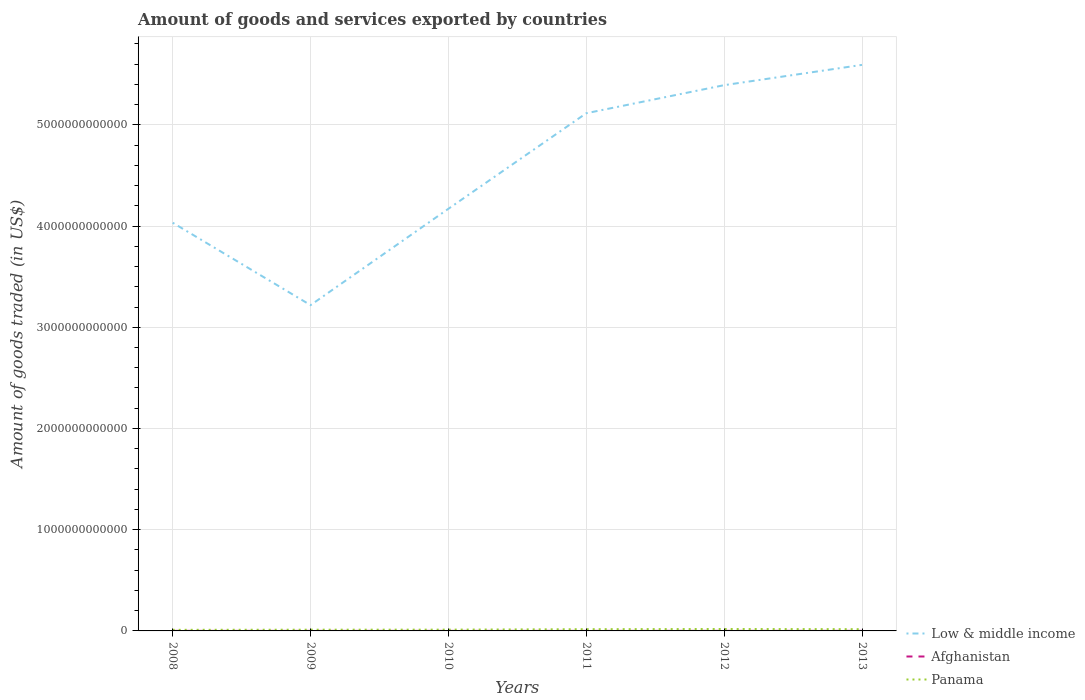How many different coloured lines are there?
Offer a terse response. 3. Is the number of lines equal to the number of legend labels?
Your answer should be compact. Yes. Across all years, what is the maximum total amount of goods and services exported in Afghanistan?
Provide a succinct answer. 4.06e+08. In which year was the total amount of goods and services exported in Panama maximum?
Offer a very short reply. 2008. What is the total total amount of goods and services exported in Low & middle income in the graph?
Your answer should be compact. -9.52e+11. What is the difference between the highest and the second highest total amount of goods and services exported in Panama?
Your answer should be compact. 8.05e+09. What is the difference between the highest and the lowest total amount of goods and services exported in Panama?
Make the answer very short. 3. Is the total amount of goods and services exported in Afghanistan strictly greater than the total amount of goods and services exported in Panama over the years?
Your answer should be compact. Yes. What is the difference between two consecutive major ticks on the Y-axis?
Give a very brief answer. 1.00e+12. Are the values on the major ticks of Y-axis written in scientific E-notation?
Ensure brevity in your answer.  No. How many legend labels are there?
Ensure brevity in your answer.  3. How are the legend labels stacked?
Provide a short and direct response. Vertical. What is the title of the graph?
Give a very brief answer. Amount of goods and services exported by countries. What is the label or title of the X-axis?
Make the answer very short. Years. What is the label or title of the Y-axis?
Your response must be concise. Amount of goods traded (in US$). What is the Amount of goods traded (in US$) of Low & middle income in 2008?
Provide a succinct answer. 4.03e+12. What is the Amount of goods traded (in US$) in Afghanistan in 2008?
Give a very brief answer. 5.63e+08. What is the Amount of goods traded (in US$) of Panama in 2008?
Give a very brief answer. 1.08e+1. What is the Amount of goods traded (in US$) of Low & middle income in 2009?
Provide a short and direct response. 3.22e+12. What is the Amount of goods traded (in US$) of Afghanistan in 2009?
Ensure brevity in your answer.  4.06e+08. What is the Amount of goods traded (in US$) of Panama in 2009?
Offer a very short reply. 1.21e+1. What is the Amount of goods traded (in US$) in Low & middle income in 2010?
Give a very brief answer. 4.17e+12. What is the Amount of goods traded (in US$) in Afghanistan in 2010?
Provide a succinct answer. 4.53e+08. What is the Amount of goods traded (in US$) in Panama in 2010?
Offer a very short reply. 1.27e+1. What is the Amount of goods traded (in US$) in Low & middle income in 2011?
Your response must be concise. 5.11e+12. What is the Amount of goods traded (in US$) in Afghanistan in 2011?
Your answer should be very brief. 4.31e+08. What is the Amount of goods traded (in US$) in Panama in 2011?
Provide a succinct answer. 1.70e+1. What is the Amount of goods traded (in US$) in Low & middle income in 2012?
Your answer should be very brief. 5.39e+12. What is the Amount of goods traded (in US$) of Afghanistan in 2012?
Make the answer very short. 6.20e+08. What is the Amount of goods traded (in US$) of Panama in 2012?
Offer a very short reply. 1.88e+1. What is the Amount of goods traded (in US$) of Low & middle income in 2013?
Provide a succinct answer. 5.59e+12. What is the Amount of goods traded (in US$) of Afghanistan in 2013?
Offer a terse response. 6.21e+08. What is the Amount of goods traded (in US$) of Panama in 2013?
Ensure brevity in your answer.  1.72e+1. Across all years, what is the maximum Amount of goods traded (in US$) in Low & middle income?
Your response must be concise. 5.59e+12. Across all years, what is the maximum Amount of goods traded (in US$) of Afghanistan?
Offer a terse response. 6.21e+08. Across all years, what is the maximum Amount of goods traded (in US$) of Panama?
Give a very brief answer. 1.88e+1. Across all years, what is the minimum Amount of goods traded (in US$) of Low & middle income?
Offer a terse response. 3.22e+12. Across all years, what is the minimum Amount of goods traded (in US$) in Afghanistan?
Your response must be concise. 4.06e+08. Across all years, what is the minimum Amount of goods traded (in US$) of Panama?
Ensure brevity in your answer.  1.08e+1. What is the total Amount of goods traded (in US$) in Low & middle income in the graph?
Your answer should be very brief. 2.75e+13. What is the total Amount of goods traded (in US$) of Afghanistan in the graph?
Offer a terse response. 3.09e+09. What is the total Amount of goods traded (in US$) in Panama in the graph?
Your answer should be compact. 8.85e+1. What is the difference between the Amount of goods traded (in US$) of Low & middle income in 2008 and that in 2009?
Your response must be concise. 8.14e+11. What is the difference between the Amount of goods traded (in US$) of Afghanistan in 2008 and that in 2009?
Your answer should be very brief. 1.57e+08. What is the difference between the Amount of goods traded (in US$) in Panama in 2008 and that in 2009?
Make the answer very short. -1.28e+09. What is the difference between the Amount of goods traded (in US$) of Low & middle income in 2008 and that in 2010?
Keep it short and to the point. -1.38e+11. What is the difference between the Amount of goods traded (in US$) of Afghanistan in 2008 and that in 2010?
Ensure brevity in your answer.  1.10e+08. What is the difference between the Amount of goods traded (in US$) of Panama in 2008 and that in 2010?
Your answer should be compact. -1.89e+09. What is the difference between the Amount of goods traded (in US$) in Low & middle income in 2008 and that in 2011?
Offer a very short reply. -1.08e+12. What is the difference between the Amount of goods traded (in US$) in Afghanistan in 2008 and that in 2011?
Your answer should be compact. 1.32e+08. What is the difference between the Amount of goods traded (in US$) in Panama in 2008 and that in 2011?
Give a very brief answer. -6.20e+09. What is the difference between the Amount of goods traded (in US$) of Low & middle income in 2008 and that in 2012?
Provide a succinct answer. -1.36e+12. What is the difference between the Amount of goods traded (in US$) of Afghanistan in 2008 and that in 2012?
Your answer should be compact. -5.67e+07. What is the difference between the Amount of goods traded (in US$) in Panama in 2008 and that in 2012?
Keep it short and to the point. -8.05e+09. What is the difference between the Amount of goods traded (in US$) in Low & middle income in 2008 and that in 2013?
Your answer should be very brief. -1.56e+12. What is the difference between the Amount of goods traded (in US$) in Afghanistan in 2008 and that in 2013?
Your response must be concise. -5.77e+07. What is the difference between the Amount of goods traded (in US$) in Panama in 2008 and that in 2013?
Your answer should be compact. -6.37e+09. What is the difference between the Amount of goods traded (in US$) in Low & middle income in 2009 and that in 2010?
Offer a terse response. -9.52e+11. What is the difference between the Amount of goods traded (in US$) of Afghanistan in 2009 and that in 2010?
Offer a very short reply. -4.72e+07. What is the difference between the Amount of goods traded (in US$) of Panama in 2009 and that in 2010?
Your response must be concise. -6.16e+08. What is the difference between the Amount of goods traded (in US$) in Low & middle income in 2009 and that in 2011?
Provide a short and direct response. -1.90e+12. What is the difference between the Amount of goods traded (in US$) of Afghanistan in 2009 and that in 2011?
Ensure brevity in your answer.  -2.45e+07. What is the difference between the Amount of goods traded (in US$) in Panama in 2009 and that in 2011?
Offer a terse response. -4.92e+09. What is the difference between the Amount of goods traded (in US$) in Low & middle income in 2009 and that in 2012?
Provide a short and direct response. -2.17e+12. What is the difference between the Amount of goods traded (in US$) of Afghanistan in 2009 and that in 2012?
Your answer should be compact. -2.14e+08. What is the difference between the Amount of goods traded (in US$) in Panama in 2009 and that in 2012?
Offer a terse response. -6.77e+09. What is the difference between the Amount of goods traded (in US$) of Low & middle income in 2009 and that in 2013?
Your answer should be very brief. -2.37e+12. What is the difference between the Amount of goods traded (in US$) of Afghanistan in 2009 and that in 2013?
Your answer should be very brief. -2.15e+08. What is the difference between the Amount of goods traded (in US$) in Panama in 2009 and that in 2013?
Make the answer very short. -5.09e+09. What is the difference between the Amount of goods traded (in US$) of Low & middle income in 2010 and that in 2011?
Your answer should be compact. -9.44e+11. What is the difference between the Amount of goods traded (in US$) of Afghanistan in 2010 and that in 2011?
Your answer should be very brief. 2.27e+07. What is the difference between the Amount of goods traded (in US$) of Panama in 2010 and that in 2011?
Provide a short and direct response. -4.30e+09. What is the difference between the Amount of goods traded (in US$) in Low & middle income in 2010 and that in 2012?
Your answer should be compact. -1.22e+12. What is the difference between the Amount of goods traded (in US$) of Afghanistan in 2010 and that in 2012?
Make the answer very short. -1.66e+08. What is the difference between the Amount of goods traded (in US$) of Panama in 2010 and that in 2012?
Keep it short and to the point. -6.15e+09. What is the difference between the Amount of goods traded (in US$) in Low & middle income in 2010 and that in 2013?
Provide a short and direct response. -1.42e+12. What is the difference between the Amount of goods traded (in US$) in Afghanistan in 2010 and that in 2013?
Your answer should be compact. -1.67e+08. What is the difference between the Amount of goods traded (in US$) in Panama in 2010 and that in 2013?
Your answer should be compact. -4.47e+09. What is the difference between the Amount of goods traded (in US$) of Low & middle income in 2011 and that in 2012?
Ensure brevity in your answer.  -2.77e+11. What is the difference between the Amount of goods traded (in US$) of Afghanistan in 2011 and that in 2012?
Provide a short and direct response. -1.89e+08. What is the difference between the Amount of goods traded (in US$) in Panama in 2011 and that in 2012?
Your answer should be very brief. -1.85e+09. What is the difference between the Amount of goods traded (in US$) of Low & middle income in 2011 and that in 2013?
Ensure brevity in your answer.  -4.78e+11. What is the difference between the Amount of goods traded (in US$) of Afghanistan in 2011 and that in 2013?
Provide a short and direct response. -1.90e+08. What is the difference between the Amount of goods traded (in US$) in Panama in 2011 and that in 2013?
Offer a terse response. -1.71e+08. What is the difference between the Amount of goods traded (in US$) of Low & middle income in 2012 and that in 2013?
Offer a terse response. -2.00e+11. What is the difference between the Amount of goods traded (in US$) of Afghanistan in 2012 and that in 2013?
Ensure brevity in your answer.  -9.86e+05. What is the difference between the Amount of goods traded (in US$) of Panama in 2012 and that in 2013?
Offer a terse response. 1.68e+09. What is the difference between the Amount of goods traded (in US$) of Low & middle income in 2008 and the Amount of goods traded (in US$) of Afghanistan in 2009?
Make the answer very short. 4.03e+12. What is the difference between the Amount of goods traded (in US$) in Low & middle income in 2008 and the Amount of goods traded (in US$) in Panama in 2009?
Your answer should be compact. 4.02e+12. What is the difference between the Amount of goods traded (in US$) of Afghanistan in 2008 and the Amount of goods traded (in US$) of Panama in 2009?
Provide a short and direct response. -1.15e+1. What is the difference between the Amount of goods traded (in US$) of Low & middle income in 2008 and the Amount of goods traded (in US$) of Afghanistan in 2010?
Give a very brief answer. 4.03e+12. What is the difference between the Amount of goods traded (in US$) of Low & middle income in 2008 and the Amount of goods traded (in US$) of Panama in 2010?
Make the answer very short. 4.02e+12. What is the difference between the Amount of goods traded (in US$) of Afghanistan in 2008 and the Amount of goods traded (in US$) of Panama in 2010?
Ensure brevity in your answer.  -1.21e+1. What is the difference between the Amount of goods traded (in US$) in Low & middle income in 2008 and the Amount of goods traded (in US$) in Afghanistan in 2011?
Provide a succinct answer. 4.03e+12. What is the difference between the Amount of goods traded (in US$) in Low & middle income in 2008 and the Amount of goods traded (in US$) in Panama in 2011?
Your answer should be compact. 4.02e+12. What is the difference between the Amount of goods traded (in US$) of Afghanistan in 2008 and the Amount of goods traded (in US$) of Panama in 2011?
Your response must be concise. -1.64e+1. What is the difference between the Amount of goods traded (in US$) of Low & middle income in 2008 and the Amount of goods traded (in US$) of Afghanistan in 2012?
Ensure brevity in your answer.  4.03e+12. What is the difference between the Amount of goods traded (in US$) in Low & middle income in 2008 and the Amount of goods traded (in US$) in Panama in 2012?
Keep it short and to the point. 4.01e+12. What is the difference between the Amount of goods traded (in US$) of Afghanistan in 2008 and the Amount of goods traded (in US$) of Panama in 2012?
Provide a short and direct response. -1.83e+1. What is the difference between the Amount of goods traded (in US$) of Low & middle income in 2008 and the Amount of goods traded (in US$) of Afghanistan in 2013?
Your answer should be compact. 4.03e+12. What is the difference between the Amount of goods traded (in US$) in Low & middle income in 2008 and the Amount of goods traded (in US$) in Panama in 2013?
Your response must be concise. 4.02e+12. What is the difference between the Amount of goods traded (in US$) of Afghanistan in 2008 and the Amount of goods traded (in US$) of Panama in 2013?
Provide a short and direct response. -1.66e+1. What is the difference between the Amount of goods traded (in US$) of Low & middle income in 2009 and the Amount of goods traded (in US$) of Afghanistan in 2010?
Offer a terse response. 3.22e+12. What is the difference between the Amount of goods traded (in US$) in Low & middle income in 2009 and the Amount of goods traded (in US$) in Panama in 2010?
Provide a short and direct response. 3.21e+12. What is the difference between the Amount of goods traded (in US$) in Afghanistan in 2009 and the Amount of goods traded (in US$) in Panama in 2010?
Make the answer very short. -1.23e+1. What is the difference between the Amount of goods traded (in US$) of Low & middle income in 2009 and the Amount of goods traded (in US$) of Afghanistan in 2011?
Your answer should be very brief. 3.22e+12. What is the difference between the Amount of goods traded (in US$) of Low & middle income in 2009 and the Amount of goods traded (in US$) of Panama in 2011?
Your answer should be very brief. 3.20e+12. What is the difference between the Amount of goods traded (in US$) in Afghanistan in 2009 and the Amount of goods traded (in US$) in Panama in 2011?
Make the answer very short. -1.66e+1. What is the difference between the Amount of goods traded (in US$) of Low & middle income in 2009 and the Amount of goods traded (in US$) of Afghanistan in 2012?
Offer a very short reply. 3.22e+12. What is the difference between the Amount of goods traded (in US$) of Low & middle income in 2009 and the Amount of goods traded (in US$) of Panama in 2012?
Keep it short and to the point. 3.20e+12. What is the difference between the Amount of goods traded (in US$) in Afghanistan in 2009 and the Amount of goods traded (in US$) in Panama in 2012?
Make the answer very short. -1.84e+1. What is the difference between the Amount of goods traded (in US$) of Low & middle income in 2009 and the Amount of goods traded (in US$) of Afghanistan in 2013?
Your answer should be compact. 3.22e+12. What is the difference between the Amount of goods traded (in US$) in Low & middle income in 2009 and the Amount of goods traded (in US$) in Panama in 2013?
Offer a terse response. 3.20e+12. What is the difference between the Amount of goods traded (in US$) of Afghanistan in 2009 and the Amount of goods traded (in US$) of Panama in 2013?
Your answer should be compact. -1.68e+1. What is the difference between the Amount of goods traded (in US$) in Low & middle income in 2010 and the Amount of goods traded (in US$) in Afghanistan in 2011?
Your response must be concise. 4.17e+12. What is the difference between the Amount of goods traded (in US$) of Low & middle income in 2010 and the Amount of goods traded (in US$) of Panama in 2011?
Offer a terse response. 4.15e+12. What is the difference between the Amount of goods traded (in US$) of Afghanistan in 2010 and the Amount of goods traded (in US$) of Panama in 2011?
Offer a very short reply. -1.65e+1. What is the difference between the Amount of goods traded (in US$) of Low & middle income in 2010 and the Amount of goods traded (in US$) of Afghanistan in 2012?
Your answer should be very brief. 4.17e+12. What is the difference between the Amount of goods traded (in US$) in Low & middle income in 2010 and the Amount of goods traded (in US$) in Panama in 2012?
Your answer should be compact. 4.15e+12. What is the difference between the Amount of goods traded (in US$) of Afghanistan in 2010 and the Amount of goods traded (in US$) of Panama in 2012?
Your answer should be compact. -1.84e+1. What is the difference between the Amount of goods traded (in US$) in Low & middle income in 2010 and the Amount of goods traded (in US$) in Afghanistan in 2013?
Offer a very short reply. 4.17e+12. What is the difference between the Amount of goods traded (in US$) of Low & middle income in 2010 and the Amount of goods traded (in US$) of Panama in 2013?
Your response must be concise. 4.15e+12. What is the difference between the Amount of goods traded (in US$) in Afghanistan in 2010 and the Amount of goods traded (in US$) in Panama in 2013?
Ensure brevity in your answer.  -1.67e+1. What is the difference between the Amount of goods traded (in US$) of Low & middle income in 2011 and the Amount of goods traded (in US$) of Afghanistan in 2012?
Offer a very short reply. 5.11e+12. What is the difference between the Amount of goods traded (in US$) in Low & middle income in 2011 and the Amount of goods traded (in US$) in Panama in 2012?
Give a very brief answer. 5.10e+12. What is the difference between the Amount of goods traded (in US$) in Afghanistan in 2011 and the Amount of goods traded (in US$) in Panama in 2012?
Your answer should be compact. -1.84e+1. What is the difference between the Amount of goods traded (in US$) in Low & middle income in 2011 and the Amount of goods traded (in US$) in Afghanistan in 2013?
Your response must be concise. 5.11e+12. What is the difference between the Amount of goods traded (in US$) in Low & middle income in 2011 and the Amount of goods traded (in US$) in Panama in 2013?
Your answer should be very brief. 5.10e+12. What is the difference between the Amount of goods traded (in US$) in Afghanistan in 2011 and the Amount of goods traded (in US$) in Panama in 2013?
Keep it short and to the point. -1.67e+1. What is the difference between the Amount of goods traded (in US$) in Low & middle income in 2012 and the Amount of goods traded (in US$) in Afghanistan in 2013?
Provide a succinct answer. 5.39e+12. What is the difference between the Amount of goods traded (in US$) of Low & middle income in 2012 and the Amount of goods traded (in US$) of Panama in 2013?
Keep it short and to the point. 5.37e+12. What is the difference between the Amount of goods traded (in US$) in Afghanistan in 2012 and the Amount of goods traded (in US$) in Panama in 2013?
Offer a terse response. -1.65e+1. What is the average Amount of goods traded (in US$) of Low & middle income per year?
Ensure brevity in your answer.  4.59e+12. What is the average Amount of goods traded (in US$) of Afghanistan per year?
Give a very brief answer. 5.16e+08. What is the average Amount of goods traded (in US$) in Panama per year?
Your answer should be compact. 1.48e+1. In the year 2008, what is the difference between the Amount of goods traded (in US$) of Low & middle income and Amount of goods traded (in US$) of Afghanistan?
Make the answer very short. 4.03e+12. In the year 2008, what is the difference between the Amount of goods traded (in US$) in Low & middle income and Amount of goods traded (in US$) in Panama?
Provide a succinct answer. 4.02e+12. In the year 2008, what is the difference between the Amount of goods traded (in US$) in Afghanistan and Amount of goods traded (in US$) in Panama?
Your answer should be very brief. -1.02e+1. In the year 2009, what is the difference between the Amount of goods traded (in US$) of Low & middle income and Amount of goods traded (in US$) of Afghanistan?
Give a very brief answer. 3.22e+12. In the year 2009, what is the difference between the Amount of goods traded (in US$) in Low & middle income and Amount of goods traded (in US$) in Panama?
Your answer should be compact. 3.21e+12. In the year 2009, what is the difference between the Amount of goods traded (in US$) in Afghanistan and Amount of goods traded (in US$) in Panama?
Your answer should be very brief. -1.17e+1. In the year 2010, what is the difference between the Amount of goods traded (in US$) in Low & middle income and Amount of goods traded (in US$) in Afghanistan?
Offer a terse response. 4.17e+12. In the year 2010, what is the difference between the Amount of goods traded (in US$) in Low & middle income and Amount of goods traded (in US$) in Panama?
Provide a short and direct response. 4.16e+12. In the year 2010, what is the difference between the Amount of goods traded (in US$) in Afghanistan and Amount of goods traded (in US$) in Panama?
Provide a succinct answer. -1.22e+1. In the year 2011, what is the difference between the Amount of goods traded (in US$) in Low & middle income and Amount of goods traded (in US$) in Afghanistan?
Provide a short and direct response. 5.11e+12. In the year 2011, what is the difference between the Amount of goods traded (in US$) of Low & middle income and Amount of goods traded (in US$) of Panama?
Your answer should be compact. 5.10e+12. In the year 2011, what is the difference between the Amount of goods traded (in US$) of Afghanistan and Amount of goods traded (in US$) of Panama?
Give a very brief answer. -1.66e+1. In the year 2012, what is the difference between the Amount of goods traded (in US$) of Low & middle income and Amount of goods traded (in US$) of Afghanistan?
Offer a terse response. 5.39e+12. In the year 2012, what is the difference between the Amount of goods traded (in US$) in Low & middle income and Amount of goods traded (in US$) in Panama?
Offer a terse response. 5.37e+12. In the year 2012, what is the difference between the Amount of goods traded (in US$) of Afghanistan and Amount of goods traded (in US$) of Panama?
Ensure brevity in your answer.  -1.82e+1. In the year 2013, what is the difference between the Amount of goods traded (in US$) in Low & middle income and Amount of goods traded (in US$) in Afghanistan?
Your response must be concise. 5.59e+12. In the year 2013, what is the difference between the Amount of goods traded (in US$) of Low & middle income and Amount of goods traded (in US$) of Panama?
Ensure brevity in your answer.  5.58e+12. In the year 2013, what is the difference between the Amount of goods traded (in US$) of Afghanistan and Amount of goods traded (in US$) of Panama?
Offer a very short reply. -1.65e+1. What is the ratio of the Amount of goods traded (in US$) in Low & middle income in 2008 to that in 2009?
Provide a short and direct response. 1.25. What is the ratio of the Amount of goods traded (in US$) of Afghanistan in 2008 to that in 2009?
Provide a succinct answer. 1.39. What is the ratio of the Amount of goods traded (in US$) in Panama in 2008 to that in 2009?
Ensure brevity in your answer.  0.89. What is the ratio of the Amount of goods traded (in US$) in Low & middle income in 2008 to that in 2010?
Provide a succinct answer. 0.97. What is the ratio of the Amount of goods traded (in US$) in Afghanistan in 2008 to that in 2010?
Keep it short and to the point. 1.24. What is the ratio of the Amount of goods traded (in US$) of Panama in 2008 to that in 2010?
Make the answer very short. 0.85. What is the ratio of the Amount of goods traded (in US$) of Low & middle income in 2008 to that in 2011?
Give a very brief answer. 0.79. What is the ratio of the Amount of goods traded (in US$) in Afghanistan in 2008 to that in 2011?
Offer a terse response. 1.31. What is the ratio of the Amount of goods traded (in US$) of Panama in 2008 to that in 2011?
Offer a very short reply. 0.64. What is the ratio of the Amount of goods traded (in US$) of Low & middle income in 2008 to that in 2012?
Provide a short and direct response. 0.75. What is the ratio of the Amount of goods traded (in US$) in Afghanistan in 2008 to that in 2012?
Your answer should be very brief. 0.91. What is the ratio of the Amount of goods traded (in US$) in Panama in 2008 to that in 2012?
Provide a short and direct response. 0.57. What is the ratio of the Amount of goods traded (in US$) of Low & middle income in 2008 to that in 2013?
Your answer should be very brief. 0.72. What is the ratio of the Amount of goods traded (in US$) of Afghanistan in 2008 to that in 2013?
Your response must be concise. 0.91. What is the ratio of the Amount of goods traded (in US$) in Panama in 2008 to that in 2013?
Provide a succinct answer. 0.63. What is the ratio of the Amount of goods traded (in US$) of Low & middle income in 2009 to that in 2010?
Your answer should be compact. 0.77. What is the ratio of the Amount of goods traded (in US$) of Afghanistan in 2009 to that in 2010?
Your answer should be compact. 0.9. What is the ratio of the Amount of goods traded (in US$) of Panama in 2009 to that in 2010?
Your answer should be compact. 0.95. What is the ratio of the Amount of goods traded (in US$) of Low & middle income in 2009 to that in 2011?
Ensure brevity in your answer.  0.63. What is the ratio of the Amount of goods traded (in US$) of Afghanistan in 2009 to that in 2011?
Your answer should be compact. 0.94. What is the ratio of the Amount of goods traded (in US$) in Panama in 2009 to that in 2011?
Your answer should be very brief. 0.71. What is the ratio of the Amount of goods traded (in US$) in Low & middle income in 2009 to that in 2012?
Provide a short and direct response. 0.6. What is the ratio of the Amount of goods traded (in US$) in Afghanistan in 2009 to that in 2012?
Your answer should be very brief. 0.66. What is the ratio of the Amount of goods traded (in US$) in Panama in 2009 to that in 2012?
Offer a very short reply. 0.64. What is the ratio of the Amount of goods traded (in US$) of Low & middle income in 2009 to that in 2013?
Provide a succinct answer. 0.58. What is the ratio of the Amount of goods traded (in US$) in Afghanistan in 2009 to that in 2013?
Make the answer very short. 0.65. What is the ratio of the Amount of goods traded (in US$) in Panama in 2009 to that in 2013?
Offer a very short reply. 0.7. What is the ratio of the Amount of goods traded (in US$) in Low & middle income in 2010 to that in 2011?
Provide a short and direct response. 0.82. What is the ratio of the Amount of goods traded (in US$) of Afghanistan in 2010 to that in 2011?
Provide a short and direct response. 1.05. What is the ratio of the Amount of goods traded (in US$) in Panama in 2010 to that in 2011?
Offer a very short reply. 0.75. What is the ratio of the Amount of goods traded (in US$) in Low & middle income in 2010 to that in 2012?
Your answer should be very brief. 0.77. What is the ratio of the Amount of goods traded (in US$) in Afghanistan in 2010 to that in 2012?
Make the answer very short. 0.73. What is the ratio of the Amount of goods traded (in US$) of Panama in 2010 to that in 2012?
Offer a very short reply. 0.67. What is the ratio of the Amount of goods traded (in US$) in Low & middle income in 2010 to that in 2013?
Offer a very short reply. 0.75. What is the ratio of the Amount of goods traded (in US$) in Afghanistan in 2010 to that in 2013?
Give a very brief answer. 0.73. What is the ratio of the Amount of goods traded (in US$) of Panama in 2010 to that in 2013?
Your answer should be very brief. 0.74. What is the ratio of the Amount of goods traded (in US$) in Low & middle income in 2011 to that in 2012?
Keep it short and to the point. 0.95. What is the ratio of the Amount of goods traded (in US$) of Afghanistan in 2011 to that in 2012?
Your response must be concise. 0.69. What is the ratio of the Amount of goods traded (in US$) in Panama in 2011 to that in 2012?
Make the answer very short. 0.9. What is the ratio of the Amount of goods traded (in US$) in Low & middle income in 2011 to that in 2013?
Your response must be concise. 0.91. What is the ratio of the Amount of goods traded (in US$) of Afghanistan in 2011 to that in 2013?
Offer a terse response. 0.69. What is the ratio of the Amount of goods traded (in US$) of Low & middle income in 2012 to that in 2013?
Offer a very short reply. 0.96. What is the ratio of the Amount of goods traded (in US$) in Afghanistan in 2012 to that in 2013?
Your response must be concise. 1. What is the ratio of the Amount of goods traded (in US$) in Panama in 2012 to that in 2013?
Ensure brevity in your answer.  1.1. What is the difference between the highest and the second highest Amount of goods traded (in US$) of Low & middle income?
Offer a very short reply. 2.00e+11. What is the difference between the highest and the second highest Amount of goods traded (in US$) in Afghanistan?
Make the answer very short. 9.86e+05. What is the difference between the highest and the second highest Amount of goods traded (in US$) of Panama?
Make the answer very short. 1.68e+09. What is the difference between the highest and the lowest Amount of goods traded (in US$) of Low & middle income?
Provide a succinct answer. 2.37e+12. What is the difference between the highest and the lowest Amount of goods traded (in US$) of Afghanistan?
Offer a terse response. 2.15e+08. What is the difference between the highest and the lowest Amount of goods traded (in US$) in Panama?
Keep it short and to the point. 8.05e+09. 